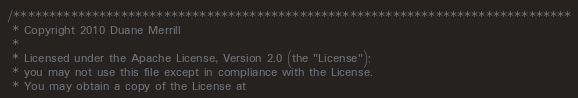Convert code to text. <code><loc_0><loc_0><loc_500><loc_500><_Cuda_>/******************************************************************************
 * Copyright 2010 Duane Merrill
 * 
 * Licensed under the Apache License, Version 2.0 (the "License");
 * you may not use this file except in compliance with the License.
 * You may obtain a copy of the License at</code> 